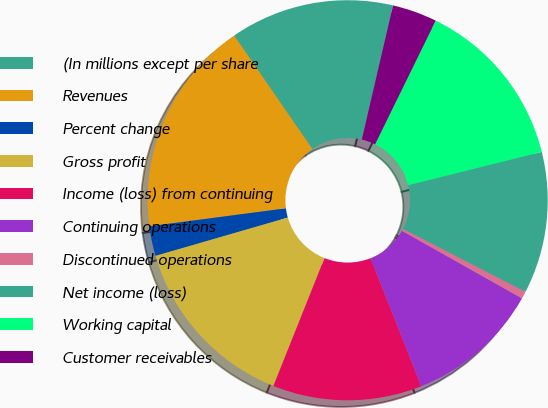Convert chart. <chart><loc_0><loc_0><loc_500><loc_500><pie_chart><fcel>(In millions except per share<fcel>Revenues<fcel>Percent change<fcel>Gross profit<fcel>Income (loss) from continuing<fcel>Continuing operations<fcel>Discontinued operations<fcel>Net income (loss)<fcel>Working capital<fcel>Customer receivables<nl><fcel>13.25%<fcel>17.47%<fcel>2.41%<fcel>14.46%<fcel>12.05%<fcel>10.84%<fcel>0.6%<fcel>11.45%<fcel>13.86%<fcel>3.61%<nl></chart> 